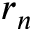<formula> <loc_0><loc_0><loc_500><loc_500>r _ { n }</formula> 